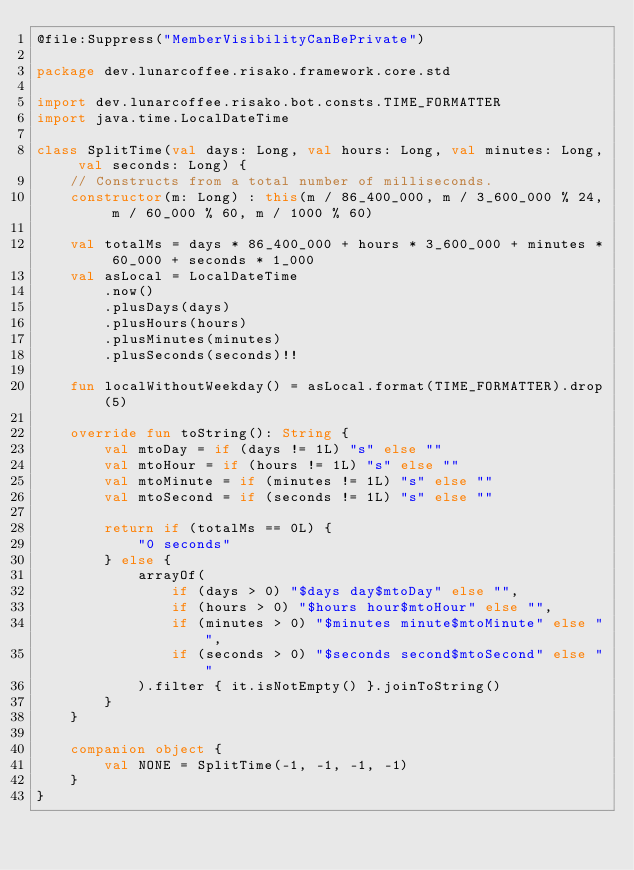Convert code to text. <code><loc_0><loc_0><loc_500><loc_500><_Kotlin_>@file:Suppress("MemberVisibilityCanBePrivate")

package dev.lunarcoffee.risako.framework.core.std

import dev.lunarcoffee.risako.bot.consts.TIME_FORMATTER
import java.time.LocalDateTime

class SplitTime(val days: Long, val hours: Long, val minutes: Long, val seconds: Long) {
    // Constructs from a total number of milliseconds.
    constructor(m: Long) : this(m / 86_400_000, m / 3_600_000 % 24, m / 60_000 % 60, m / 1000 % 60)

    val totalMs = days * 86_400_000 + hours * 3_600_000 + minutes * 60_000 + seconds * 1_000
    val asLocal = LocalDateTime
        .now()
        .plusDays(days)
        .plusHours(hours)
        .plusMinutes(minutes)
        .plusSeconds(seconds)!!

    fun localWithoutWeekday() = asLocal.format(TIME_FORMATTER).drop(5)

    override fun toString(): String {
        val mtoDay = if (days != 1L) "s" else ""
        val mtoHour = if (hours != 1L) "s" else ""
        val mtoMinute = if (minutes != 1L) "s" else ""
        val mtoSecond = if (seconds != 1L) "s" else ""

        return if (totalMs == 0L) {
            "0 seconds"
        } else {
            arrayOf(
                if (days > 0) "$days day$mtoDay" else "",
                if (hours > 0) "$hours hour$mtoHour" else "",
                if (minutes > 0) "$minutes minute$mtoMinute" else "",
                if (seconds > 0) "$seconds second$mtoSecond" else ""
            ).filter { it.isNotEmpty() }.joinToString()
        }
    }

    companion object {
        val NONE = SplitTime(-1, -1, -1, -1)
    }
}
</code> 